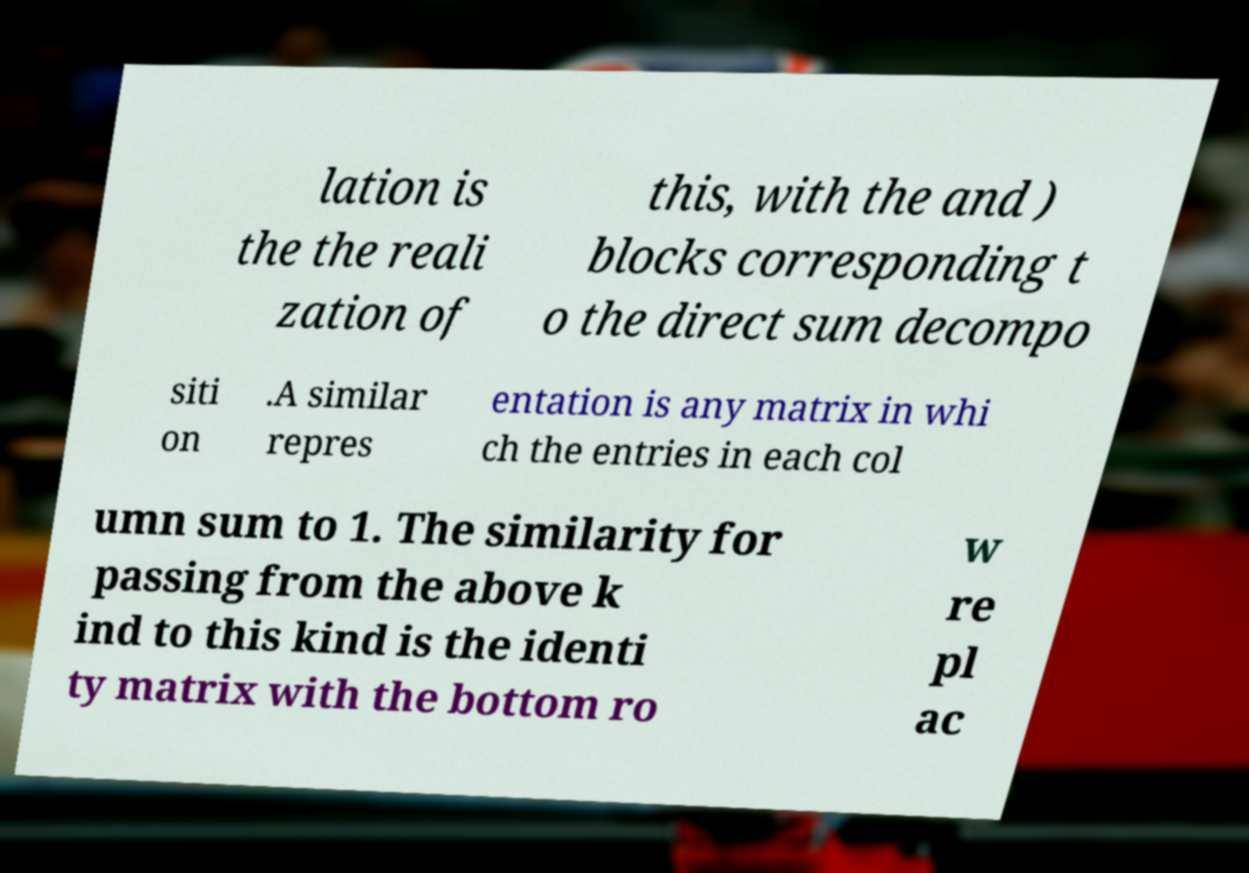Could you extract and type out the text from this image? lation is the the reali zation of this, with the and ) blocks corresponding t o the direct sum decompo siti on .A similar repres entation is any matrix in whi ch the entries in each col umn sum to 1. The similarity for passing from the above k ind to this kind is the identi ty matrix with the bottom ro w re pl ac 